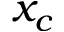<formula> <loc_0><loc_0><loc_500><loc_500>x _ { c }</formula> 